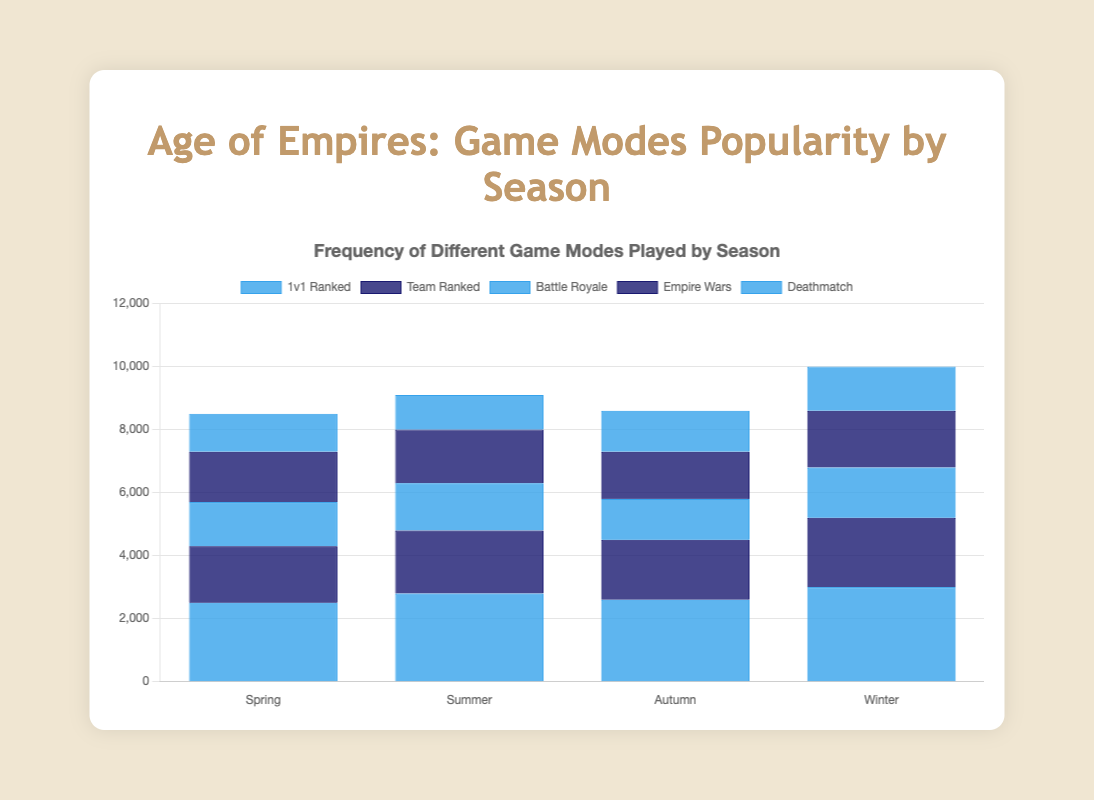What is the most played game mode in Winter? Look at the height of the bars for Winter. The tallest bar corresponds to the game mode with the highest frequency. In Winter, the highest bar is for "1v1 Ranked" at 3000.
Answer: 1v1 Ranked Which season has the lowest frequency for the "Deathmatch" mode? Compare the heights of the bars for the Deathmatch game mode in each season. The shortest bar represents the lowest frequency. In Summer, the "Deathmatch" bar is the shortest at 1100.
Answer: Summer What is the total frequency of "Empire Wars" played across all seasons? Add the frequencies of "Empire Wars" from all the seasons: Spring (1600) + Summer (1700) + Autumn (1500) + Winter (1800). The total is 1600 + 1700 + 1500 + 1800 = 6600.
Answer: 6600 How does the frequency of "Team Ranked" in Summer compare to Spring? Compare the heights of the "Team Ranked" bars in Summer and Spring. In Spring, the frequency is 1800 while in Summer, it is 2000. Since 2000 is greater than 1800, "Team Ranked" is played more in Summer.
Answer: Summer What are the game modes that have a higher frequency in Winter compared to Autumn? Compare the heights of bars from Winter and Autumn for each game mode, and identify which bars in Winter are taller than those in Autumn. "1v1 Ranked" (3000 vs 2600), "Team Ranked" (2200 vs 1900), "Battle Royale" (1600 vs 1300), "Empire Wars" (1800 vs 1500), and "Deathmatch" (1400 vs 1300) in Winter are all higher than in Autumn.
Answer: 1v1 Ranked, Team Ranked, Battle Royale, Empire Wars, Deathmatch Which season has the highest total frequency for all game modes combined? Calculate the total frequency for each season by summing up the frequencies of all game modes within each season: Spring (2500 + 1800 + 1400 + 1600 + 1200 = 8500), Summer (2800 + 2000 + 1500 + 1700 + 1100 = 9100), Autumn (2600 + 1900 + 1300 + 1500 + 1300 = 8600), Winter (3000 + 2200 + 1600 + 1800 + 1400 = 10000). Winter has the highest total frequency of 10000.
Answer: Winter Which game mode saw the least fluctuation in frequency across the seasons? Assess the difference between the maximum and minimum frequencies for each game mode across all seasons and identify the smallest range. "Deathmatch" fluctuates between 1100 and 1400, giving a range of 300.
Answer: Deathmatch What is the combined frequency for "1v1 Ranked" and "Team Ranked" in Spring? Add the frequencies of "1v1 Ranked" and "Team Ranked" in Spring. The frequency of "1v1 Ranked" is 2500 and "Team Ranked" is 1800. The combined frequency is 2500 + 1800 = 4300.
Answer: 4300 